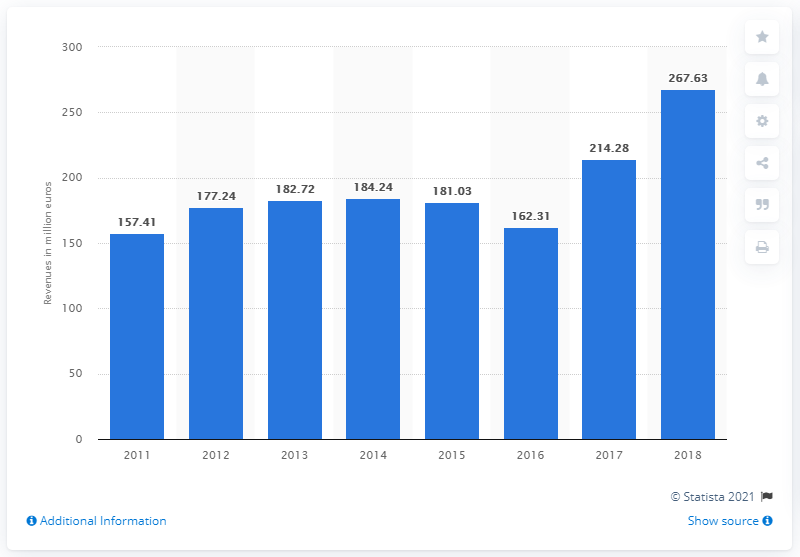Highlight a few significant elements in this photo. The total revenue of Guccio Gucci S.p.A. in 2018 was 267.63... In 2018, the revenue of Guccio Gucci S.p.A. was 214.28 million. 